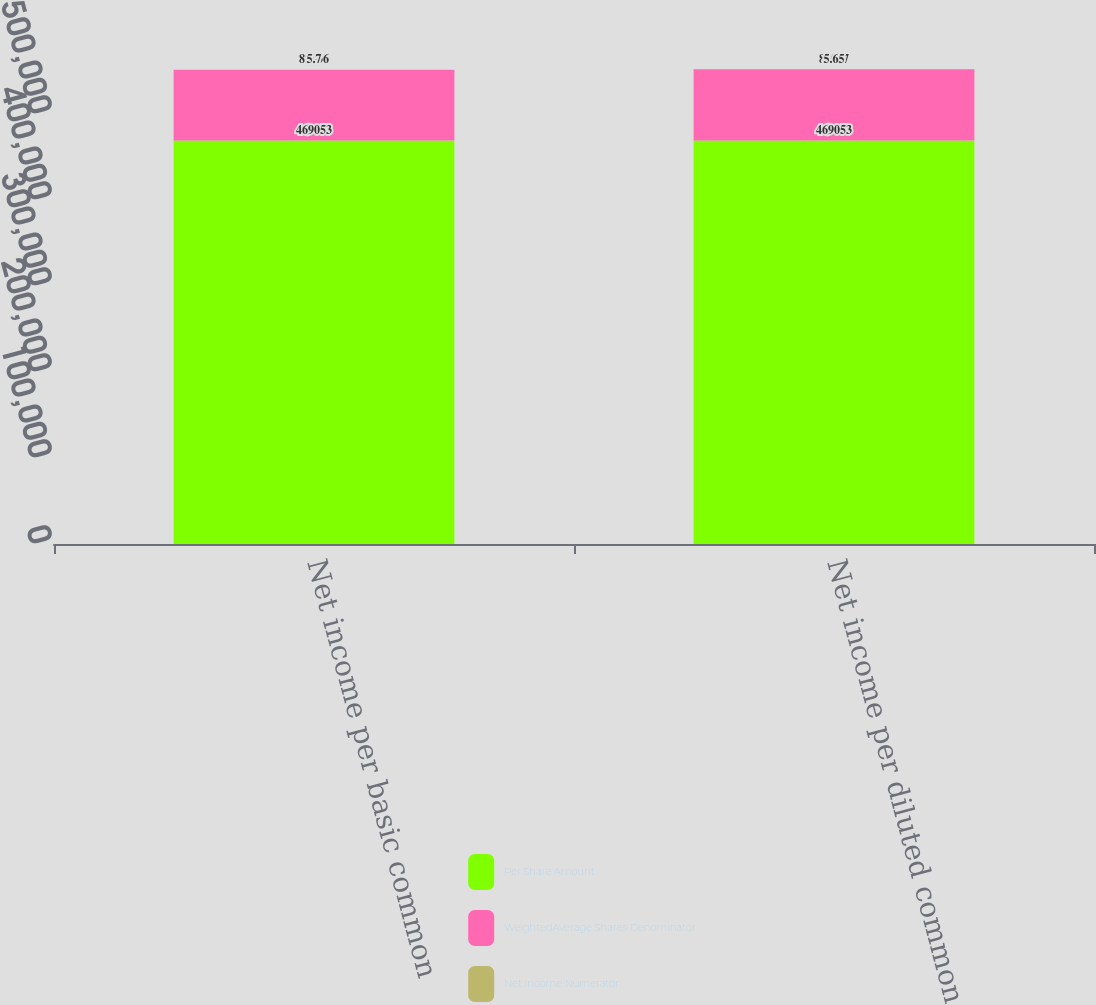Convert chart to OTSL. <chart><loc_0><loc_0><loc_500><loc_500><stacked_bar_chart><ecel><fcel>Net income per basic common<fcel>Net income per diluted common<nl><fcel>Per Share Amount<fcel>469053<fcel>469053<nl><fcel>WeightedAverage Shares Denominator<fcel>82336<fcel>83087<nl><fcel>Net Income Numerator<fcel>5.7<fcel>5.65<nl></chart> 